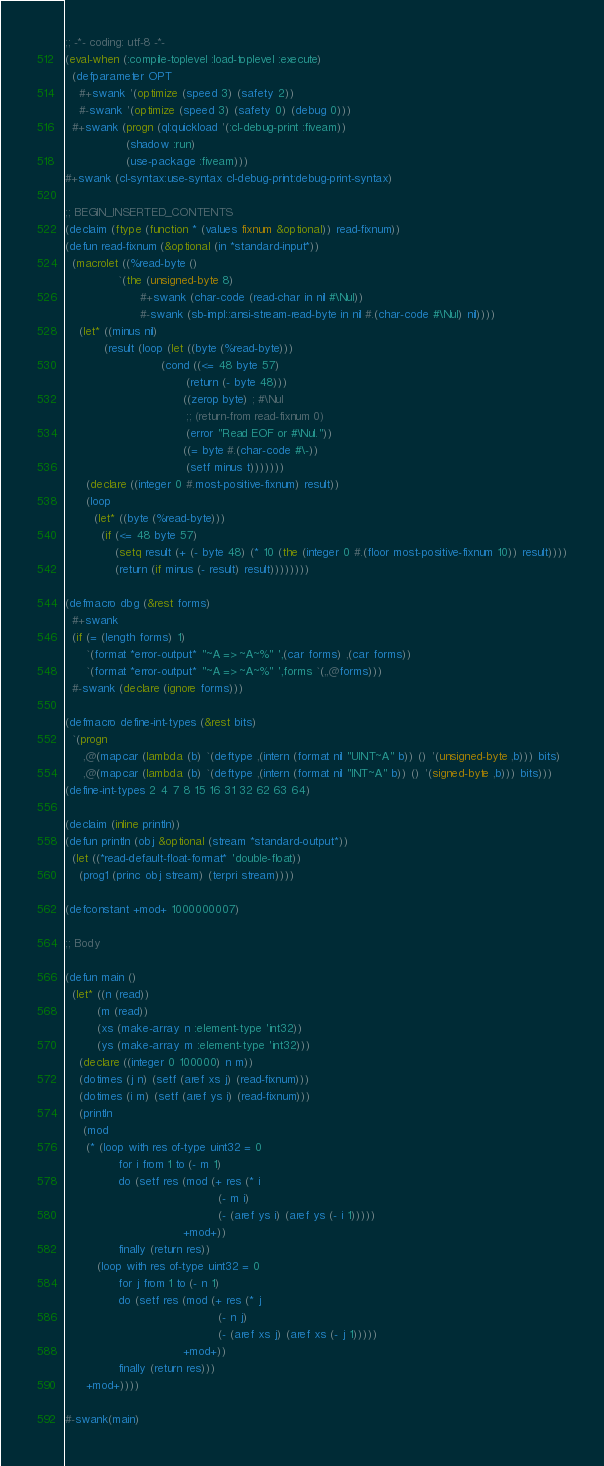Convert code to text. <code><loc_0><loc_0><loc_500><loc_500><_Lisp_>;; -*- coding: utf-8 -*-
(eval-when (:compile-toplevel :load-toplevel :execute)
  (defparameter OPT
    #+swank '(optimize (speed 3) (safety 2))
    #-swank '(optimize (speed 3) (safety 0) (debug 0)))
  #+swank (progn (ql:quickload '(:cl-debug-print :fiveam))
                 (shadow :run)
                 (use-package :fiveam)))
#+swank (cl-syntax:use-syntax cl-debug-print:debug-print-syntax)

;; BEGIN_INSERTED_CONTENTS
(declaim (ftype (function * (values fixnum &optional)) read-fixnum))
(defun read-fixnum (&optional (in *standard-input*))
  (macrolet ((%read-byte ()
               `(the (unsigned-byte 8)
                     #+swank (char-code (read-char in nil #\Nul))
                     #-swank (sb-impl::ansi-stream-read-byte in nil #.(char-code #\Nul) nil))))
    (let* ((minus nil)
           (result (loop (let ((byte (%read-byte)))
                           (cond ((<= 48 byte 57)
                                  (return (- byte 48)))
                                 ((zerop byte) ; #\Nul
                                  ;; (return-from read-fixnum 0)
                                  (error "Read EOF or #\Nul."))
                                 ((= byte #.(char-code #\-))
                                  (setf minus t)))))))
      (declare ((integer 0 #.most-positive-fixnum) result))
      (loop
        (let* ((byte (%read-byte)))
          (if (<= 48 byte 57)
              (setq result (+ (- byte 48) (* 10 (the (integer 0 #.(floor most-positive-fixnum 10)) result))))
              (return (if minus (- result) result))))))))

(defmacro dbg (&rest forms)
  #+swank
  (if (= (length forms) 1)
      `(format *error-output* "~A => ~A~%" ',(car forms) ,(car forms))
      `(format *error-output* "~A => ~A~%" ',forms `(,,@forms)))
  #-swank (declare (ignore forms)))

(defmacro define-int-types (&rest bits)
  `(progn
     ,@(mapcar (lambda (b) `(deftype ,(intern (format nil "UINT~A" b)) () '(unsigned-byte ,b))) bits)
     ,@(mapcar (lambda (b) `(deftype ,(intern (format nil "INT~A" b)) () '(signed-byte ,b))) bits)))
(define-int-types 2 4 7 8 15 16 31 32 62 63 64)

(declaim (inline println))
(defun println (obj &optional (stream *standard-output*))
  (let ((*read-default-float-format* 'double-float))
    (prog1 (princ obj stream) (terpri stream))))

(defconstant +mod+ 1000000007)

;; Body

(defun main ()
  (let* ((n (read))
         (m (read))
         (xs (make-array n :element-type 'int32))
         (ys (make-array m :element-type 'int32)))
    (declare ((integer 0 100000) n m))
    (dotimes (j n) (setf (aref xs j) (read-fixnum)))
    (dotimes (i m) (setf (aref ys i) (read-fixnum)))
    (println
     (mod
      (* (loop with res of-type uint32 = 0
               for i from 1 to (- m 1)
               do (setf res (mod (+ res (* i
                                           (- m i)
                                           (- (aref ys i) (aref ys (- i 1)))))
                                 +mod+))
               finally (return res))
         (loop with res of-type uint32 = 0
               for j from 1 to (- n 1)
               do (setf res (mod (+ res (* j
                                           (- n j)
                                           (- (aref xs j) (aref xs (- j 1)))))
                                 +mod+))
               finally (return res)))
      +mod+))))

#-swank(main)
</code> 